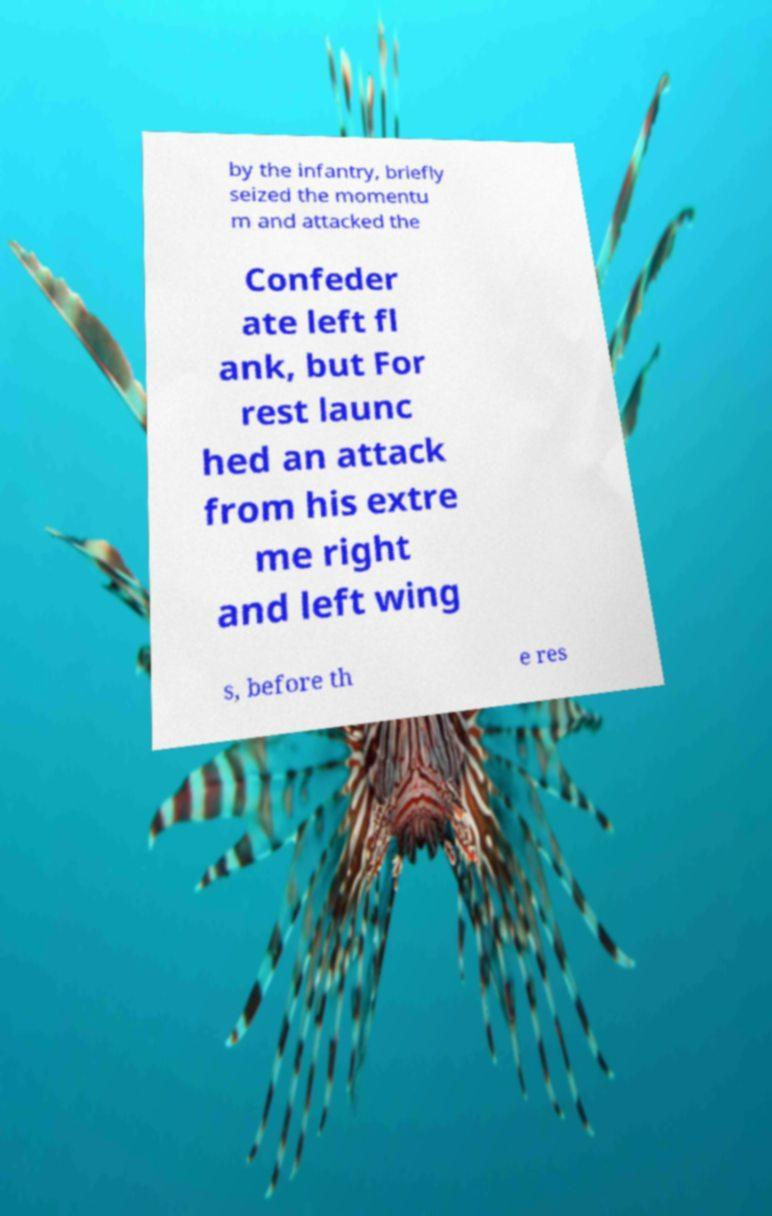Could you extract and type out the text from this image? by the infantry, briefly seized the momentu m and attacked the Confeder ate left fl ank, but For rest launc hed an attack from his extre me right and left wing s, before th e res 